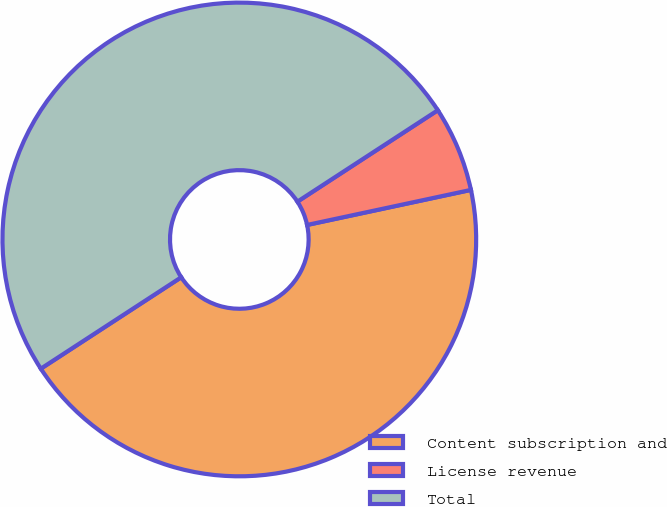Convert chart. <chart><loc_0><loc_0><loc_500><loc_500><pie_chart><fcel>Content subscription and<fcel>License revenue<fcel>Total<nl><fcel>44.17%<fcel>5.83%<fcel>50.0%<nl></chart> 